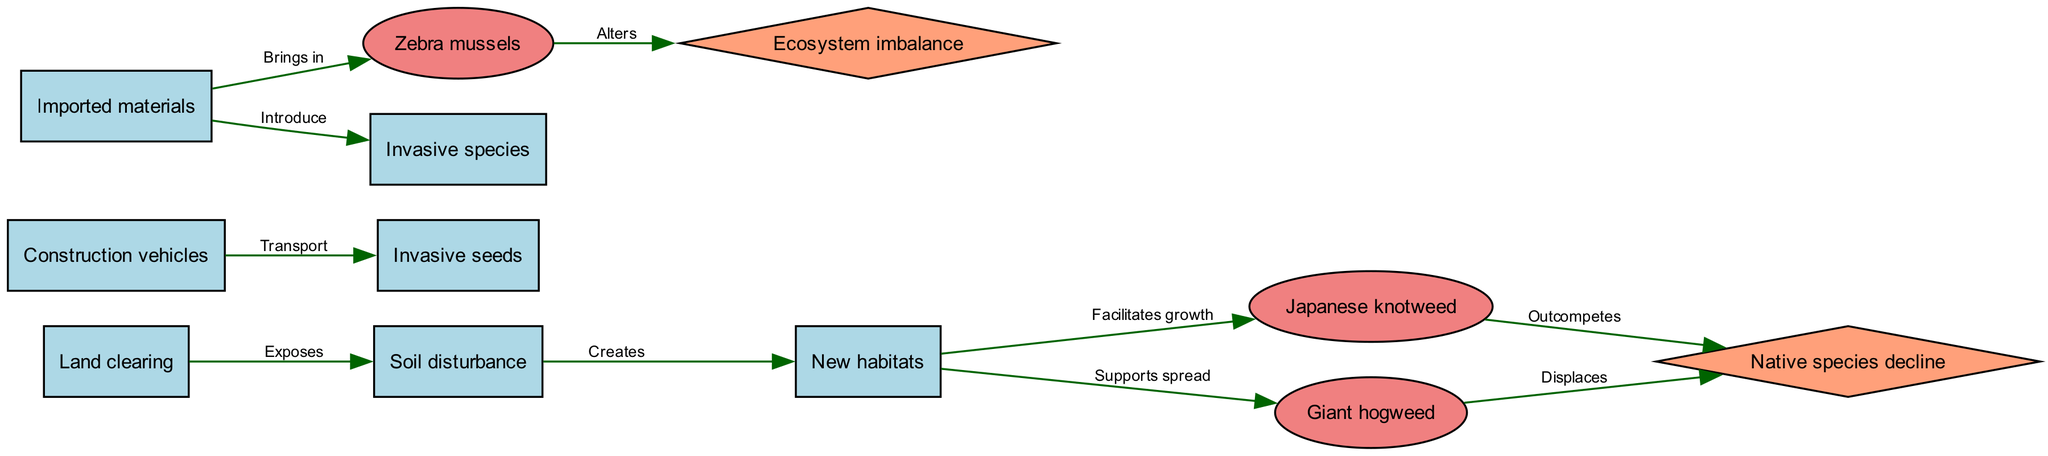What is the total number of nodes in the diagram? The diagram lists 10 nodes in total, which are: Land clearing, Construction vehicles, Soil disturbance, Imported materials, New habitats, Japanese knotweed, Giant hogweed, Zebra mussels, Native species decline, and Ecosystem imbalance.
Answer: 10 What is the relationship between "Imported materials" and "Invasive species"? The edge shows that "Imported materials" introduces "Invasive species," indicating that construction inputs can bring non-native flora and fauna into new areas.
Answer: Introduce Which invasive species is linked to the disruption of "Native species decline"? According to the diagram, "Japanese knotweed" and "Giant hogweed" both connect to "Native species decline," indicating that these species negatively affect native biodiversity.
Answer: Japanese knotweed, Giant hogweed How many edges start from "New habitats"? The diagram indicates that there are two edges emanating from "New habitats," leading to "Japanese knotweed" and "Giant hogweed."
Answer: 2 What does "Construction vehicles" transport? The directed edge shows that "Construction vehicles" transport "Invasive seeds," which are capable of establishing themselves in disturbed areas.
Answer: Invasive seeds What is the impact of "Zebra mussels" as per their relationship in the diagram? "Zebra mussels" alter "Ecosystem imbalance," indicating they disrupt the local aquatic ecology once introduced through human means.
Answer: Alters How do "Japanese knotweed" and "Giant hogweed" relate to "Native species decline"? "Japanese knotweed" outcompetes native species, while "Giant hogweed" displaces them, illustrating the dual threat they pose to native biodiversity in altered habitats.
Answer: Outcompetes, Displaces What do "Soil disturbance" and "Land clearing" have in common? "Soil disturbance" is caused by "Land clearing," which highlights the prerequisite actions on the land that lead to ecological changes.
Answer: Exposes What is the consequence of "New habitats" on the invasive species listed? The edge indicates that "New habitats" facilitate the growth of "Japanese knotweed" and support the spread of "Giant hogweed," promoting further invasion.
Answer: Facilitates growth, Supports spread 